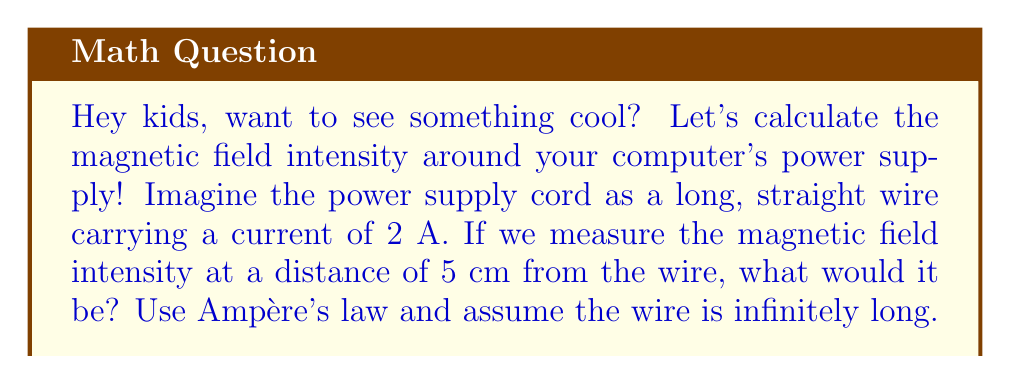Can you solve this math problem? Let's solve this step-by-step using Ampère's law:

1) Ampère's law for a long, straight wire is given by:

   $$B = \frac{\mu_0 I}{2\pi r}$$

   where:
   $B$ is the magnetic field intensity
   $\mu_0$ is the permeability of free space ($4\pi \times 10^{-7}$ T⋅m/A)
   $I$ is the current in the wire
   $r$ is the distance from the wire

2) We're given:
   $I = 2$ A
   $r = 5$ cm $= 0.05$ m

3) Let's substitute these values into the equation:

   $$B = \frac{(4\pi \times 10^{-7})(2)}{2\pi(0.05)}$$

4) Simplify:

   $$B = \frac{8\pi \times 10^{-7}}{2\pi(0.05)} = \frac{4 \times 10^{-7}}{0.05} = 8 \times 10^{-6}$$ T

5) Convert to microtesla (μT):

   $$B = 8 \text{ μT}$$

So, the magnetic field intensity at 5 cm from the power supply cord is 8 μT.
Answer: 8 μT 